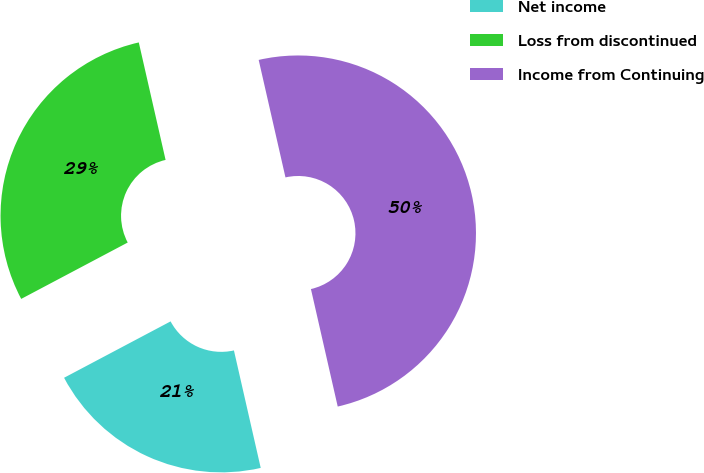Convert chart to OTSL. <chart><loc_0><loc_0><loc_500><loc_500><pie_chart><fcel>Net income<fcel>Loss from discontinued<fcel>Income from Continuing<nl><fcel>20.82%<fcel>29.18%<fcel>50.0%<nl></chart> 